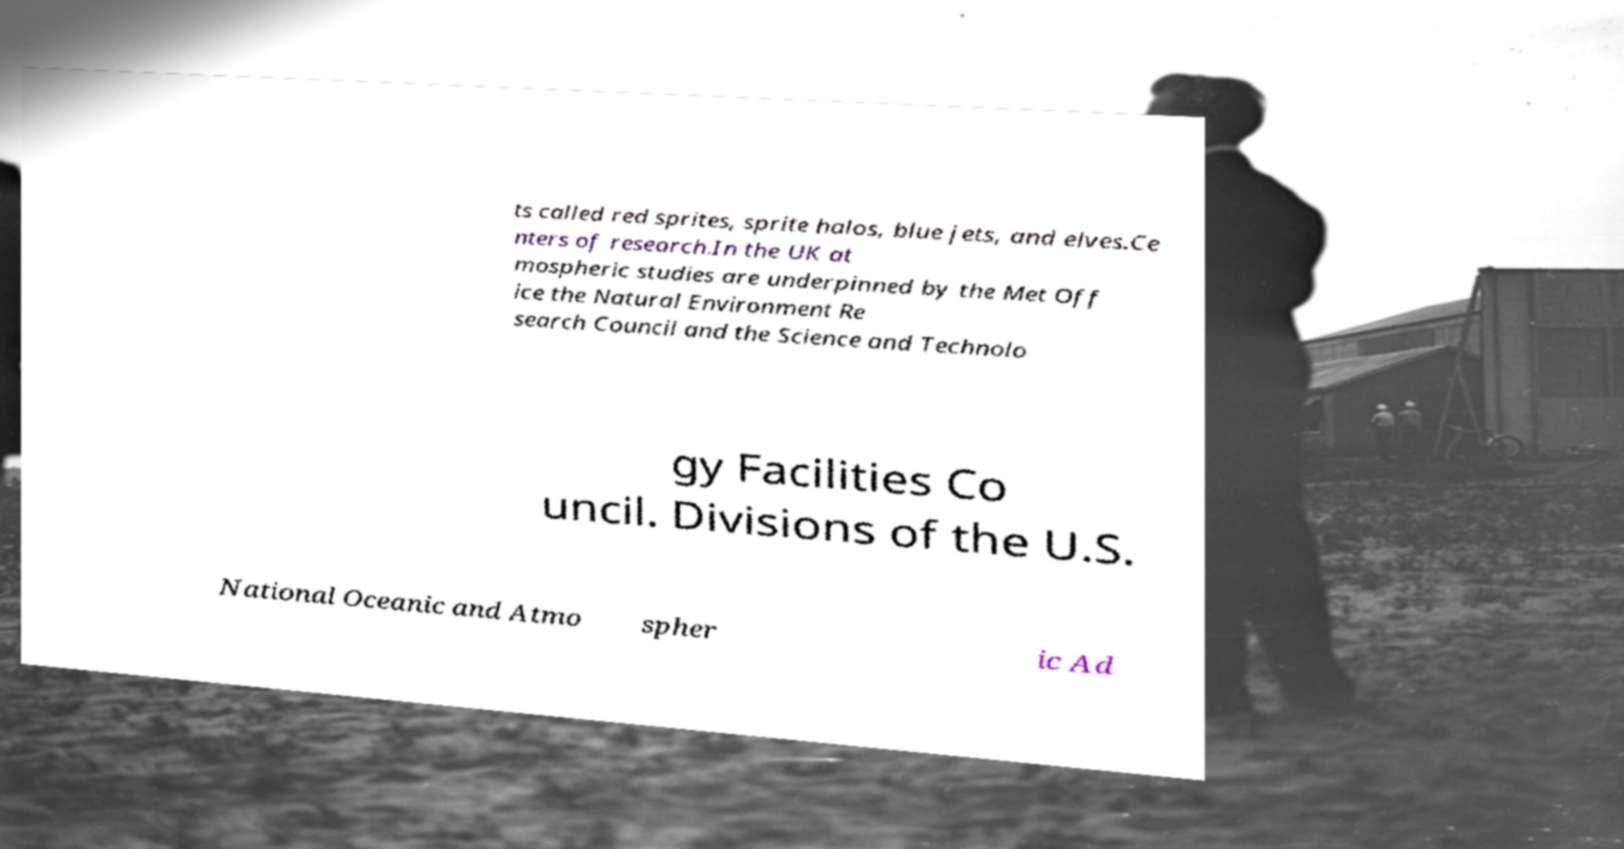Please identify and transcribe the text found in this image. ts called red sprites, sprite halos, blue jets, and elves.Ce nters of research.In the UK at mospheric studies are underpinned by the Met Off ice the Natural Environment Re search Council and the Science and Technolo gy Facilities Co uncil. Divisions of the U.S. National Oceanic and Atmo spher ic Ad 